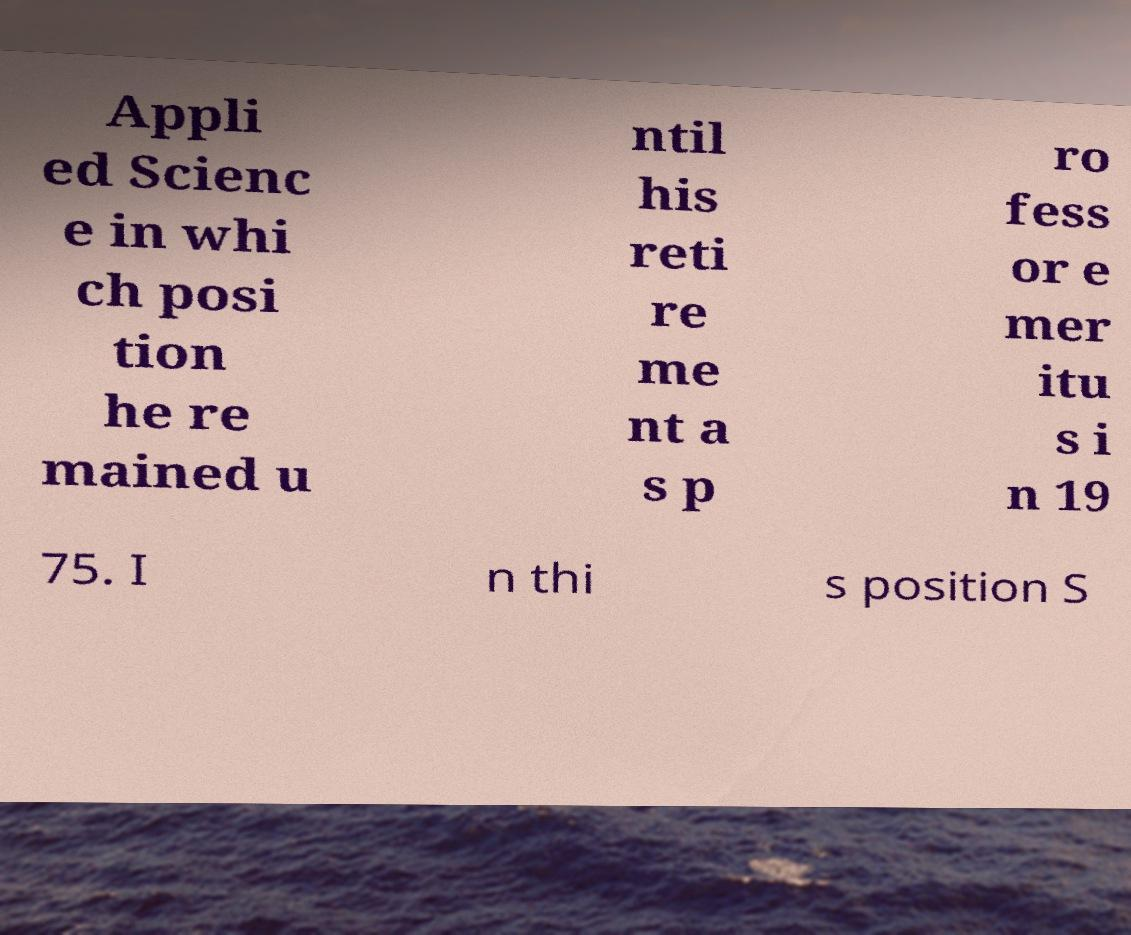I need the written content from this picture converted into text. Can you do that? Appli ed Scienc e in whi ch posi tion he re mained u ntil his reti re me nt a s p ro fess or e mer itu s i n 19 75. I n thi s position S 